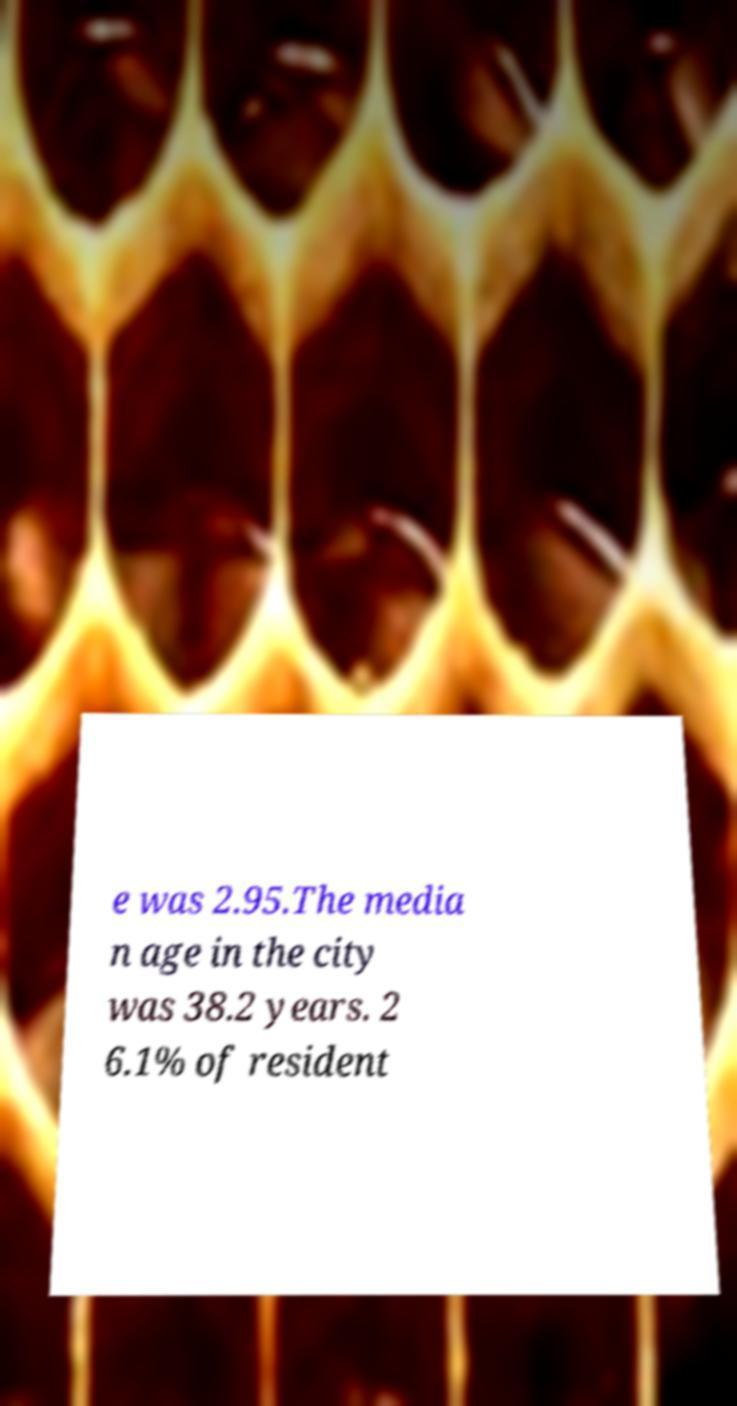Can you read and provide the text displayed in the image?This photo seems to have some interesting text. Can you extract and type it out for me? e was 2.95.The media n age in the city was 38.2 years. 2 6.1% of resident 